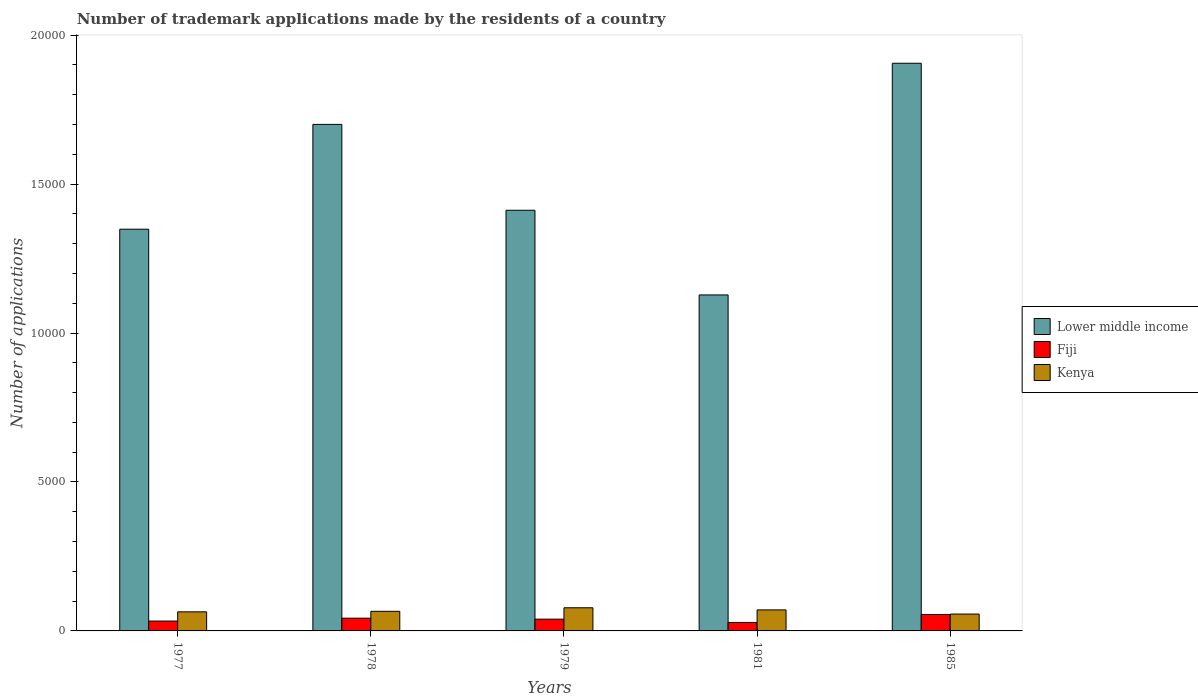Are the number of bars per tick equal to the number of legend labels?
Make the answer very short. Yes. Are the number of bars on each tick of the X-axis equal?
Your answer should be very brief. Yes. How many bars are there on the 3rd tick from the right?
Offer a very short reply. 3. What is the label of the 4th group of bars from the left?
Provide a short and direct response. 1981. What is the number of trademark applications made by the residents in Lower middle income in 1978?
Your answer should be compact. 1.70e+04. Across all years, what is the maximum number of trademark applications made by the residents in Fiji?
Your response must be concise. 552. Across all years, what is the minimum number of trademark applications made by the residents in Kenya?
Give a very brief answer. 566. In which year was the number of trademark applications made by the residents in Kenya maximum?
Your answer should be compact. 1979. What is the total number of trademark applications made by the residents in Fiji in the graph?
Your answer should be compact. 1990. What is the difference between the number of trademark applications made by the residents in Lower middle income in 1977 and that in 1985?
Offer a terse response. -5571. What is the difference between the number of trademark applications made by the residents in Fiji in 1981 and the number of trademark applications made by the residents in Lower middle income in 1979?
Offer a terse response. -1.38e+04. What is the average number of trademark applications made by the residents in Kenya per year?
Ensure brevity in your answer.  669.6. In the year 1981, what is the difference between the number of trademark applications made by the residents in Lower middle income and number of trademark applications made by the residents in Fiji?
Offer a very short reply. 1.10e+04. What is the ratio of the number of trademark applications made by the residents in Kenya in 1979 to that in 1981?
Your response must be concise. 1.1. Is the difference between the number of trademark applications made by the residents in Lower middle income in 1981 and 1985 greater than the difference between the number of trademark applications made by the residents in Fiji in 1981 and 1985?
Give a very brief answer. No. What is the difference between the highest and the second highest number of trademark applications made by the residents in Lower middle income?
Give a very brief answer. 2052. What is the difference between the highest and the lowest number of trademark applications made by the residents in Lower middle income?
Offer a terse response. 7778. In how many years, is the number of trademark applications made by the residents in Fiji greater than the average number of trademark applications made by the residents in Fiji taken over all years?
Your answer should be compact. 2. What does the 3rd bar from the left in 1977 represents?
Offer a terse response. Kenya. What does the 3rd bar from the right in 1977 represents?
Your response must be concise. Lower middle income. Is it the case that in every year, the sum of the number of trademark applications made by the residents in Kenya and number of trademark applications made by the residents in Lower middle income is greater than the number of trademark applications made by the residents in Fiji?
Provide a succinct answer. Yes. Are all the bars in the graph horizontal?
Keep it short and to the point. No. What is the difference between two consecutive major ticks on the Y-axis?
Your response must be concise. 5000. Are the values on the major ticks of Y-axis written in scientific E-notation?
Offer a very short reply. No. Where does the legend appear in the graph?
Provide a short and direct response. Center right. How many legend labels are there?
Keep it short and to the point. 3. What is the title of the graph?
Offer a terse response. Number of trademark applications made by the residents of a country. Does "Tuvalu" appear as one of the legend labels in the graph?
Keep it short and to the point. No. What is the label or title of the Y-axis?
Offer a terse response. Number of applications. What is the Number of applications of Lower middle income in 1977?
Keep it short and to the point. 1.35e+04. What is the Number of applications of Fiji in 1977?
Ensure brevity in your answer.  331. What is the Number of applications of Kenya in 1977?
Offer a terse response. 641. What is the Number of applications of Lower middle income in 1978?
Keep it short and to the point. 1.70e+04. What is the Number of applications in Fiji in 1978?
Provide a short and direct response. 428. What is the Number of applications of Kenya in 1978?
Keep it short and to the point. 658. What is the Number of applications of Lower middle income in 1979?
Provide a succinct answer. 1.41e+04. What is the Number of applications of Fiji in 1979?
Ensure brevity in your answer.  395. What is the Number of applications of Kenya in 1979?
Provide a succinct answer. 777. What is the Number of applications in Lower middle income in 1981?
Ensure brevity in your answer.  1.13e+04. What is the Number of applications of Fiji in 1981?
Your answer should be very brief. 284. What is the Number of applications in Kenya in 1981?
Give a very brief answer. 706. What is the Number of applications in Lower middle income in 1985?
Your answer should be very brief. 1.91e+04. What is the Number of applications of Fiji in 1985?
Your response must be concise. 552. What is the Number of applications in Kenya in 1985?
Give a very brief answer. 566. Across all years, what is the maximum Number of applications in Lower middle income?
Your answer should be compact. 1.91e+04. Across all years, what is the maximum Number of applications in Fiji?
Give a very brief answer. 552. Across all years, what is the maximum Number of applications in Kenya?
Offer a terse response. 777. Across all years, what is the minimum Number of applications of Lower middle income?
Your answer should be compact. 1.13e+04. Across all years, what is the minimum Number of applications in Fiji?
Offer a very short reply. 284. Across all years, what is the minimum Number of applications in Kenya?
Your answer should be very brief. 566. What is the total Number of applications in Lower middle income in the graph?
Provide a succinct answer. 7.50e+04. What is the total Number of applications in Fiji in the graph?
Ensure brevity in your answer.  1990. What is the total Number of applications of Kenya in the graph?
Keep it short and to the point. 3348. What is the difference between the Number of applications in Lower middle income in 1977 and that in 1978?
Give a very brief answer. -3519. What is the difference between the Number of applications in Fiji in 1977 and that in 1978?
Make the answer very short. -97. What is the difference between the Number of applications in Lower middle income in 1977 and that in 1979?
Your answer should be compact. -636. What is the difference between the Number of applications in Fiji in 1977 and that in 1979?
Provide a succinct answer. -64. What is the difference between the Number of applications in Kenya in 1977 and that in 1979?
Keep it short and to the point. -136. What is the difference between the Number of applications in Lower middle income in 1977 and that in 1981?
Make the answer very short. 2207. What is the difference between the Number of applications of Fiji in 1977 and that in 1981?
Your response must be concise. 47. What is the difference between the Number of applications in Kenya in 1977 and that in 1981?
Ensure brevity in your answer.  -65. What is the difference between the Number of applications in Lower middle income in 1977 and that in 1985?
Offer a terse response. -5571. What is the difference between the Number of applications of Fiji in 1977 and that in 1985?
Make the answer very short. -221. What is the difference between the Number of applications in Lower middle income in 1978 and that in 1979?
Ensure brevity in your answer.  2883. What is the difference between the Number of applications of Fiji in 1978 and that in 1979?
Give a very brief answer. 33. What is the difference between the Number of applications of Kenya in 1978 and that in 1979?
Keep it short and to the point. -119. What is the difference between the Number of applications in Lower middle income in 1978 and that in 1981?
Keep it short and to the point. 5726. What is the difference between the Number of applications in Fiji in 1978 and that in 1981?
Provide a succinct answer. 144. What is the difference between the Number of applications in Kenya in 1978 and that in 1981?
Make the answer very short. -48. What is the difference between the Number of applications in Lower middle income in 1978 and that in 1985?
Your answer should be compact. -2052. What is the difference between the Number of applications of Fiji in 1978 and that in 1985?
Keep it short and to the point. -124. What is the difference between the Number of applications of Kenya in 1978 and that in 1985?
Provide a succinct answer. 92. What is the difference between the Number of applications in Lower middle income in 1979 and that in 1981?
Make the answer very short. 2843. What is the difference between the Number of applications of Fiji in 1979 and that in 1981?
Your answer should be very brief. 111. What is the difference between the Number of applications of Lower middle income in 1979 and that in 1985?
Your answer should be very brief. -4935. What is the difference between the Number of applications in Fiji in 1979 and that in 1985?
Make the answer very short. -157. What is the difference between the Number of applications of Kenya in 1979 and that in 1985?
Provide a succinct answer. 211. What is the difference between the Number of applications in Lower middle income in 1981 and that in 1985?
Offer a terse response. -7778. What is the difference between the Number of applications in Fiji in 1981 and that in 1985?
Offer a terse response. -268. What is the difference between the Number of applications of Kenya in 1981 and that in 1985?
Offer a terse response. 140. What is the difference between the Number of applications in Lower middle income in 1977 and the Number of applications in Fiji in 1978?
Provide a short and direct response. 1.31e+04. What is the difference between the Number of applications in Lower middle income in 1977 and the Number of applications in Kenya in 1978?
Give a very brief answer. 1.28e+04. What is the difference between the Number of applications in Fiji in 1977 and the Number of applications in Kenya in 1978?
Ensure brevity in your answer.  -327. What is the difference between the Number of applications of Lower middle income in 1977 and the Number of applications of Fiji in 1979?
Your answer should be very brief. 1.31e+04. What is the difference between the Number of applications in Lower middle income in 1977 and the Number of applications in Kenya in 1979?
Offer a very short reply. 1.27e+04. What is the difference between the Number of applications of Fiji in 1977 and the Number of applications of Kenya in 1979?
Give a very brief answer. -446. What is the difference between the Number of applications of Lower middle income in 1977 and the Number of applications of Fiji in 1981?
Give a very brief answer. 1.32e+04. What is the difference between the Number of applications of Lower middle income in 1977 and the Number of applications of Kenya in 1981?
Give a very brief answer. 1.28e+04. What is the difference between the Number of applications in Fiji in 1977 and the Number of applications in Kenya in 1981?
Your answer should be very brief. -375. What is the difference between the Number of applications in Lower middle income in 1977 and the Number of applications in Fiji in 1985?
Your answer should be very brief. 1.29e+04. What is the difference between the Number of applications of Lower middle income in 1977 and the Number of applications of Kenya in 1985?
Make the answer very short. 1.29e+04. What is the difference between the Number of applications in Fiji in 1977 and the Number of applications in Kenya in 1985?
Your answer should be compact. -235. What is the difference between the Number of applications in Lower middle income in 1978 and the Number of applications in Fiji in 1979?
Keep it short and to the point. 1.66e+04. What is the difference between the Number of applications of Lower middle income in 1978 and the Number of applications of Kenya in 1979?
Offer a very short reply. 1.62e+04. What is the difference between the Number of applications in Fiji in 1978 and the Number of applications in Kenya in 1979?
Give a very brief answer. -349. What is the difference between the Number of applications of Lower middle income in 1978 and the Number of applications of Fiji in 1981?
Your response must be concise. 1.67e+04. What is the difference between the Number of applications in Lower middle income in 1978 and the Number of applications in Kenya in 1981?
Your answer should be very brief. 1.63e+04. What is the difference between the Number of applications of Fiji in 1978 and the Number of applications of Kenya in 1981?
Provide a succinct answer. -278. What is the difference between the Number of applications of Lower middle income in 1978 and the Number of applications of Fiji in 1985?
Your answer should be very brief. 1.65e+04. What is the difference between the Number of applications of Lower middle income in 1978 and the Number of applications of Kenya in 1985?
Make the answer very short. 1.64e+04. What is the difference between the Number of applications of Fiji in 1978 and the Number of applications of Kenya in 1985?
Your answer should be very brief. -138. What is the difference between the Number of applications of Lower middle income in 1979 and the Number of applications of Fiji in 1981?
Provide a short and direct response. 1.38e+04. What is the difference between the Number of applications in Lower middle income in 1979 and the Number of applications in Kenya in 1981?
Give a very brief answer. 1.34e+04. What is the difference between the Number of applications in Fiji in 1979 and the Number of applications in Kenya in 1981?
Make the answer very short. -311. What is the difference between the Number of applications of Lower middle income in 1979 and the Number of applications of Fiji in 1985?
Provide a short and direct response. 1.36e+04. What is the difference between the Number of applications of Lower middle income in 1979 and the Number of applications of Kenya in 1985?
Offer a terse response. 1.36e+04. What is the difference between the Number of applications in Fiji in 1979 and the Number of applications in Kenya in 1985?
Ensure brevity in your answer.  -171. What is the difference between the Number of applications in Lower middle income in 1981 and the Number of applications in Fiji in 1985?
Make the answer very short. 1.07e+04. What is the difference between the Number of applications of Lower middle income in 1981 and the Number of applications of Kenya in 1985?
Offer a terse response. 1.07e+04. What is the difference between the Number of applications in Fiji in 1981 and the Number of applications in Kenya in 1985?
Provide a succinct answer. -282. What is the average Number of applications in Lower middle income per year?
Make the answer very short. 1.50e+04. What is the average Number of applications in Fiji per year?
Your answer should be compact. 398. What is the average Number of applications of Kenya per year?
Provide a short and direct response. 669.6. In the year 1977, what is the difference between the Number of applications of Lower middle income and Number of applications of Fiji?
Give a very brief answer. 1.32e+04. In the year 1977, what is the difference between the Number of applications in Lower middle income and Number of applications in Kenya?
Give a very brief answer. 1.28e+04. In the year 1977, what is the difference between the Number of applications of Fiji and Number of applications of Kenya?
Ensure brevity in your answer.  -310. In the year 1978, what is the difference between the Number of applications in Lower middle income and Number of applications in Fiji?
Offer a very short reply. 1.66e+04. In the year 1978, what is the difference between the Number of applications of Lower middle income and Number of applications of Kenya?
Your answer should be compact. 1.63e+04. In the year 1978, what is the difference between the Number of applications in Fiji and Number of applications in Kenya?
Your answer should be very brief. -230. In the year 1979, what is the difference between the Number of applications of Lower middle income and Number of applications of Fiji?
Make the answer very short. 1.37e+04. In the year 1979, what is the difference between the Number of applications of Lower middle income and Number of applications of Kenya?
Give a very brief answer. 1.33e+04. In the year 1979, what is the difference between the Number of applications of Fiji and Number of applications of Kenya?
Provide a succinct answer. -382. In the year 1981, what is the difference between the Number of applications in Lower middle income and Number of applications in Fiji?
Your response must be concise. 1.10e+04. In the year 1981, what is the difference between the Number of applications of Lower middle income and Number of applications of Kenya?
Offer a terse response. 1.06e+04. In the year 1981, what is the difference between the Number of applications in Fiji and Number of applications in Kenya?
Your answer should be compact. -422. In the year 1985, what is the difference between the Number of applications of Lower middle income and Number of applications of Fiji?
Offer a very short reply. 1.85e+04. In the year 1985, what is the difference between the Number of applications in Lower middle income and Number of applications in Kenya?
Ensure brevity in your answer.  1.85e+04. In the year 1985, what is the difference between the Number of applications of Fiji and Number of applications of Kenya?
Offer a very short reply. -14. What is the ratio of the Number of applications of Lower middle income in 1977 to that in 1978?
Provide a short and direct response. 0.79. What is the ratio of the Number of applications in Fiji in 1977 to that in 1978?
Your answer should be compact. 0.77. What is the ratio of the Number of applications in Kenya in 1977 to that in 1978?
Ensure brevity in your answer.  0.97. What is the ratio of the Number of applications in Lower middle income in 1977 to that in 1979?
Offer a terse response. 0.95. What is the ratio of the Number of applications in Fiji in 1977 to that in 1979?
Give a very brief answer. 0.84. What is the ratio of the Number of applications of Kenya in 1977 to that in 1979?
Ensure brevity in your answer.  0.82. What is the ratio of the Number of applications in Lower middle income in 1977 to that in 1981?
Provide a short and direct response. 1.2. What is the ratio of the Number of applications in Fiji in 1977 to that in 1981?
Offer a terse response. 1.17. What is the ratio of the Number of applications in Kenya in 1977 to that in 1981?
Your answer should be compact. 0.91. What is the ratio of the Number of applications of Lower middle income in 1977 to that in 1985?
Your response must be concise. 0.71. What is the ratio of the Number of applications of Fiji in 1977 to that in 1985?
Keep it short and to the point. 0.6. What is the ratio of the Number of applications of Kenya in 1977 to that in 1985?
Make the answer very short. 1.13. What is the ratio of the Number of applications in Lower middle income in 1978 to that in 1979?
Your response must be concise. 1.2. What is the ratio of the Number of applications of Fiji in 1978 to that in 1979?
Your response must be concise. 1.08. What is the ratio of the Number of applications in Kenya in 1978 to that in 1979?
Give a very brief answer. 0.85. What is the ratio of the Number of applications in Lower middle income in 1978 to that in 1981?
Offer a terse response. 1.51. What is the ratio of the Number of applications in Fiji in 1978 to that in 1981?
Ensure brevity in your answer.  1.51. What is the ratio of the Number of applications of Kenya in 1978 to that in 1981?
Offer a very short reply. 0.93. What is the ratio of the Number of applications of Lower middle income in 1978 to that in 1985?
Offer a very short reply. 0.89. What is the ratio of the Number of applications in Fiji in 1978 to that in 1985?
Keep it short and to the point. 0.78. What is the ratio of the Number of applications in Kenya in 1978 to that in 1985?
Keep it short and to the point. 1.16. What is the ratio of the Number of applications in Lower middle income in 1979 to that in 1981?
Offer a terse response. 1.25. What is the ratio of the Number of applications of Fiji in 1979 to that in 1981?
Offer a very short reply. 1.39. What is the ratio of the Number of applications in Kenya in 1979 to that in 1981?
Ensure brevity in your answer.  1.1. What is the ratio of the Number of applications in Lower middle income in 1979 to that in 1985?
Your answer should be compact. 0.74. What is the ratio of the Number of applications of Fiji in 1979 to that in 1985?
Offer a very short reply. 0.72. What is the ratio of the Number of applications of Kenya in 1979 to that in 1985?
Provide a short and direct response. 1.37. What is the ratio of the Number of applications in Lower middle income in 1981 to that in 1985?
Give a very brief answer. 0.59. What is the ratio of the Number of applications in Fiji in 1981 to that in 1985?
Your answer should be compact. 0.51. What is the ratio of the Number of applications of Kenya in 1981 to that in 1985?
Make the answer very short. 1.25. What is the difference between the highest and the second highest Number of applications in Lower middle income?
Your answer should be compact. 2052. What is the difference between the highest and the second highest Number of applications in Fiji?
Your response must be concise. 124. What is the difference between the highest and the lowest Number of applications of Lower middle income?
Your answer should be very brief. 7778. What is the difference between the highest and the lowest Number of applications in Fiji?
Keep it short and to the point. 268. What is the difference between the highest and the lowest Number of applications of Kenya?
Make the answer very short. 211. 